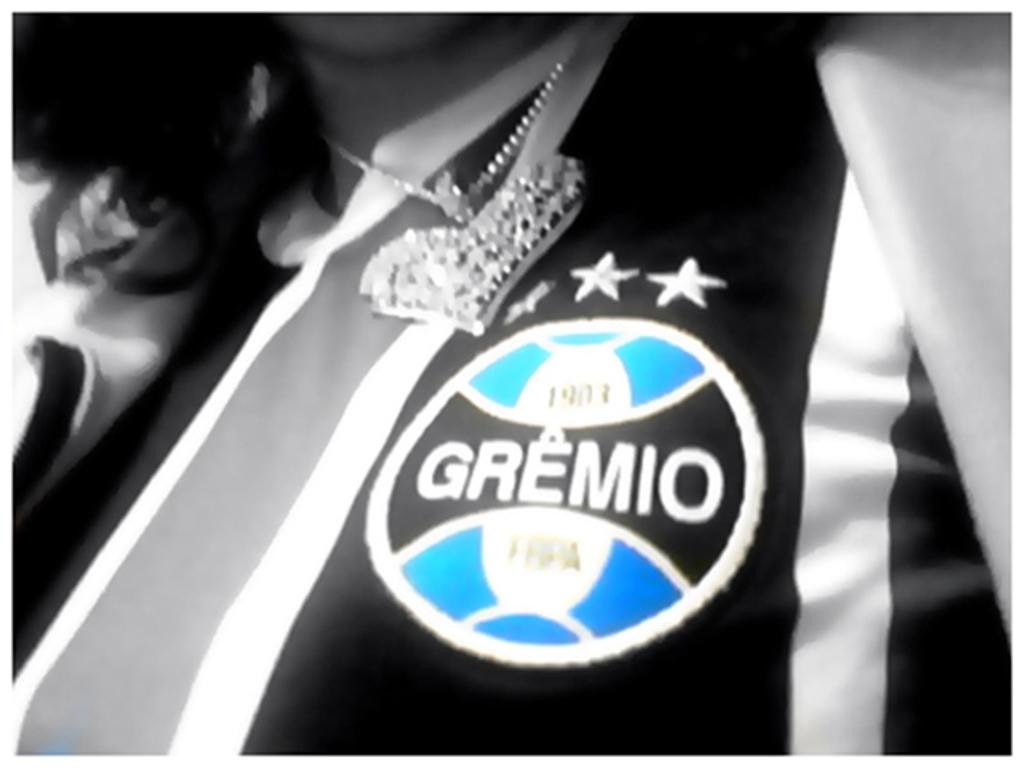Who or what is present in the image? There is a person in the image. What is the person wearing in the image? The person is wearing a chain. What type of coal is being used to comb the person's hair in the image? There is no coal or combing activity present in the image. 